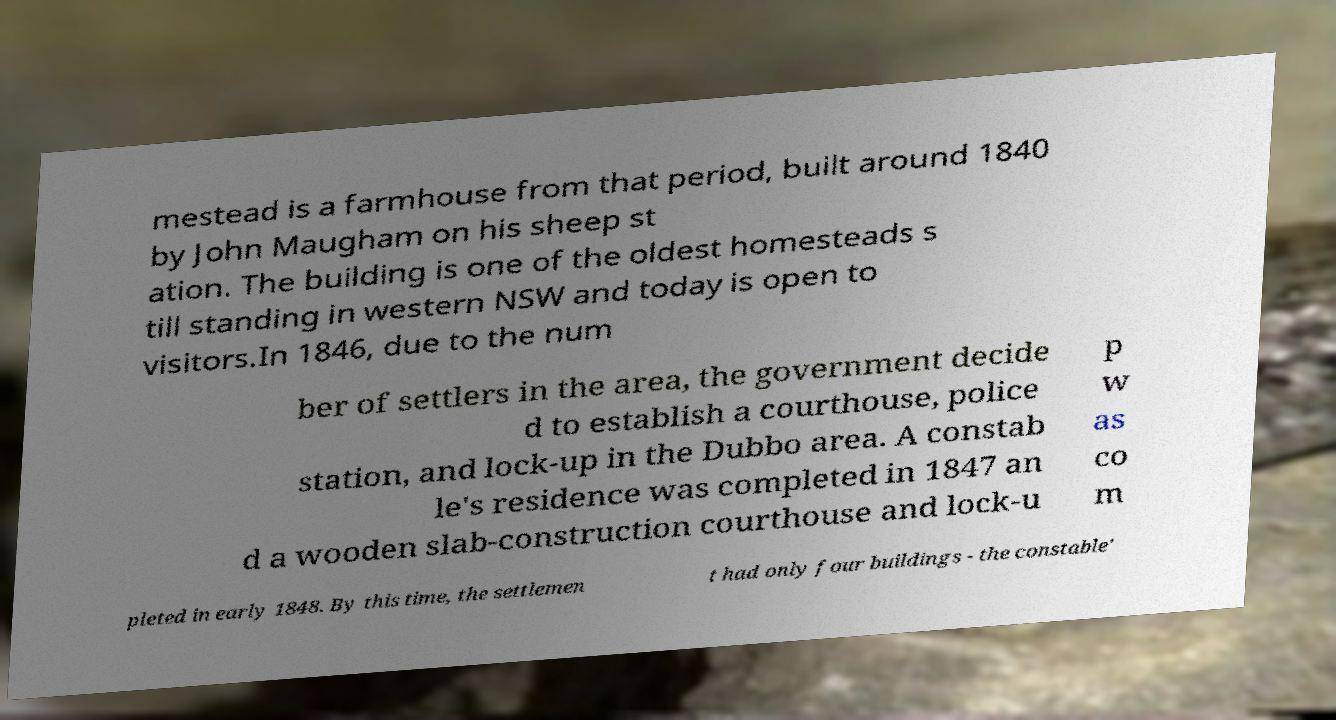For documentation purposes, I need the text within this image transcribed. Could you provide that? mestead is a farmhouse from that period, built around 1840 by John Maugham on his sheep st ation. The building is one of the oldest homesteads s till standing in western NSW and today is open to visitors.In 1846, due to the num ber of settlers in the area, the government decide d to establish a courthouse, police station, and lock-up in the Dubbo area. A constab le's residence was completed in 1847 an d a wooden slab-construction courthouse and lock-u p w as co m pleted in early 1848. By this time, the settlemen t had only four buildings - the constable' 